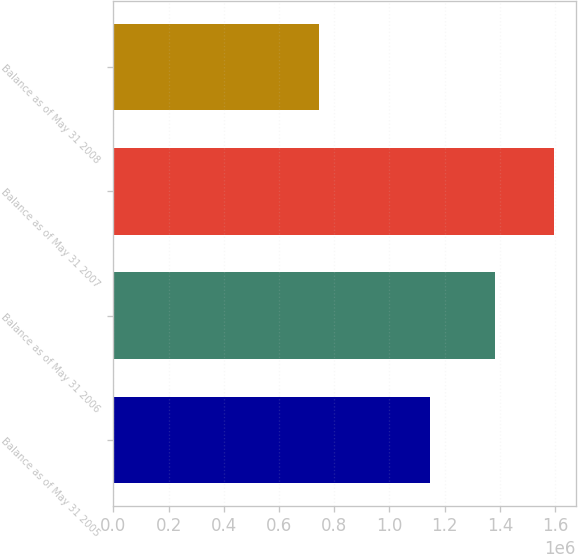Convert chart. <chart><loc_0><loc_0><loc_500><loc_500><bar_chart><fcel>Balance as of May 31 2005<fcel>Balance as of May 31 2006<fcel>Balance as of May 31 2007<fcel>Balance as of May 31 2008<nl><fcel>1.14761e+06<fcel>1.38097e+06<fcel>1.5951e+06<fcel>745351<nl></chart> 